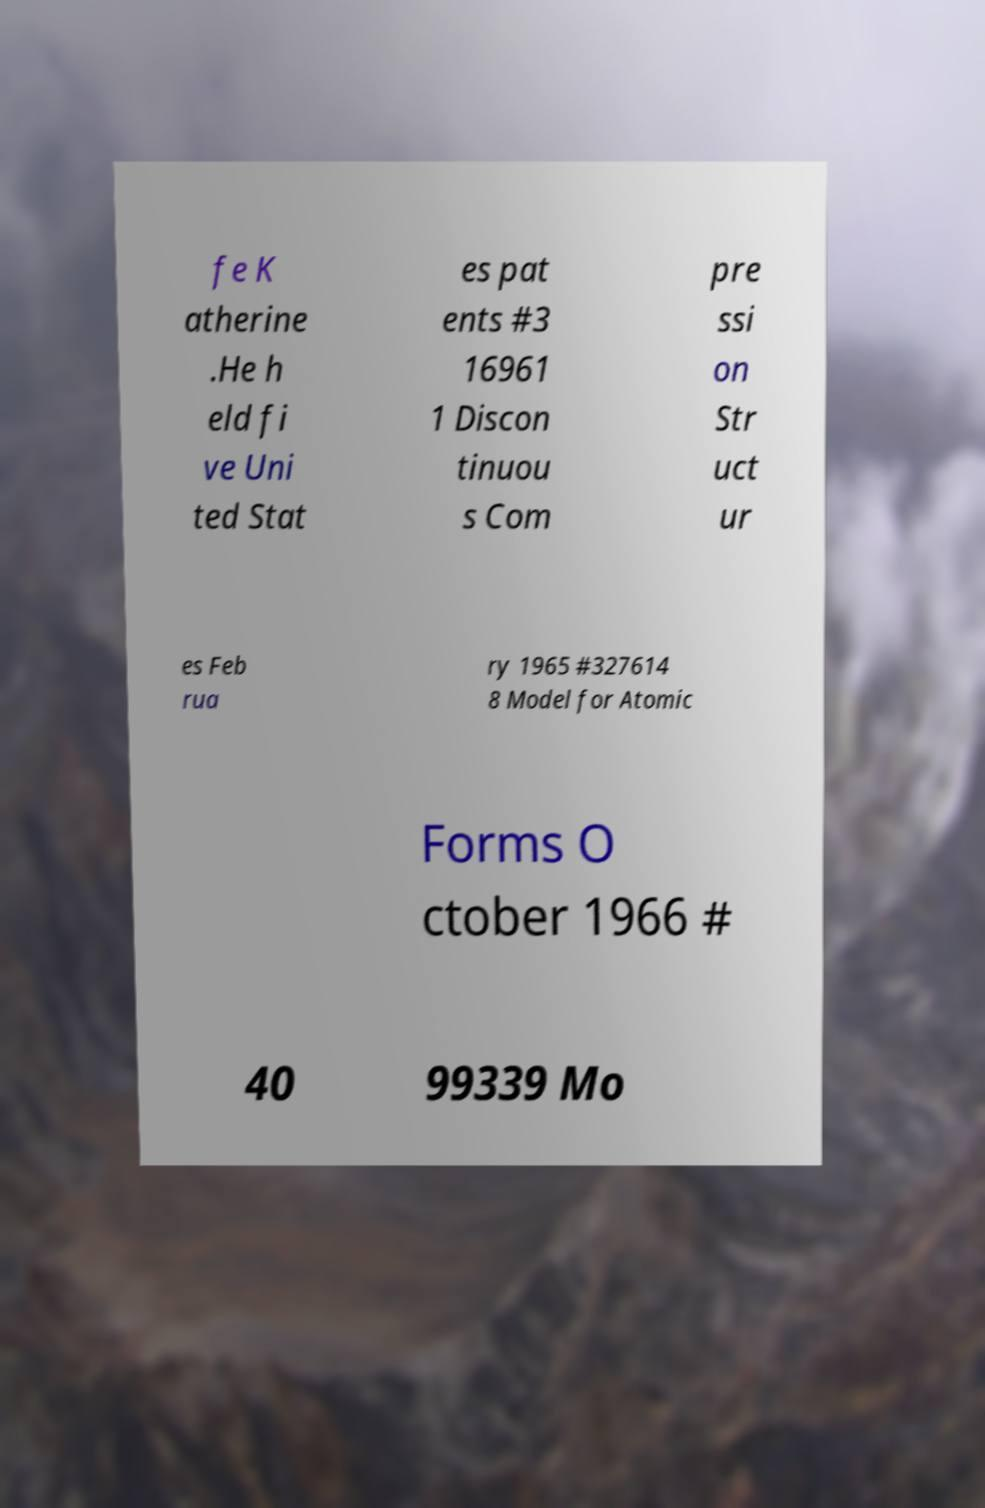Can you read and provide the text displayed in the image?This photo seems to have some interesting text. Can you extract and type it out for me? fe K atherine .He h eld fi ve Uni ted Stat es pat ents #3 16961 1 Discon tinuou s Com pre ssi on Str uct ur es Feb rua ry 1965 #327614 8 Model for Atomic Forms O ctober 1966 # 40 99339 Mo 